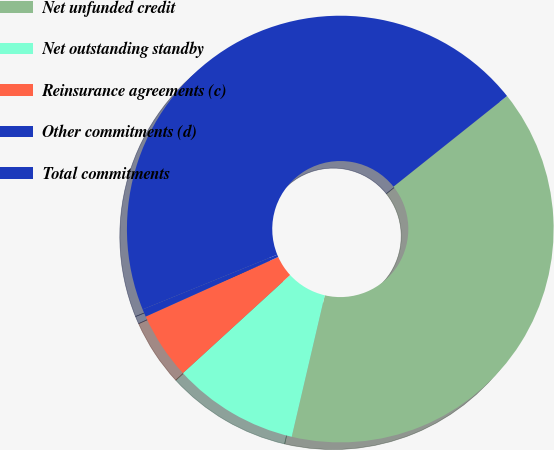Convert chart to OTSL. <chart><loc_0><loc_0><loc_500><loc_500><pie_chart><fcel>Net unfunded credit<fcel>Net outstanding standby<fcel>Reinsurance agreements (c)<fcel>Other commitments (d)<fcel>Total commitments<nl><fcel>39.37%<fcel>9.55%<fcel>5.07%<fcel>0.58%<fcel>45.43%<nl></chart> 